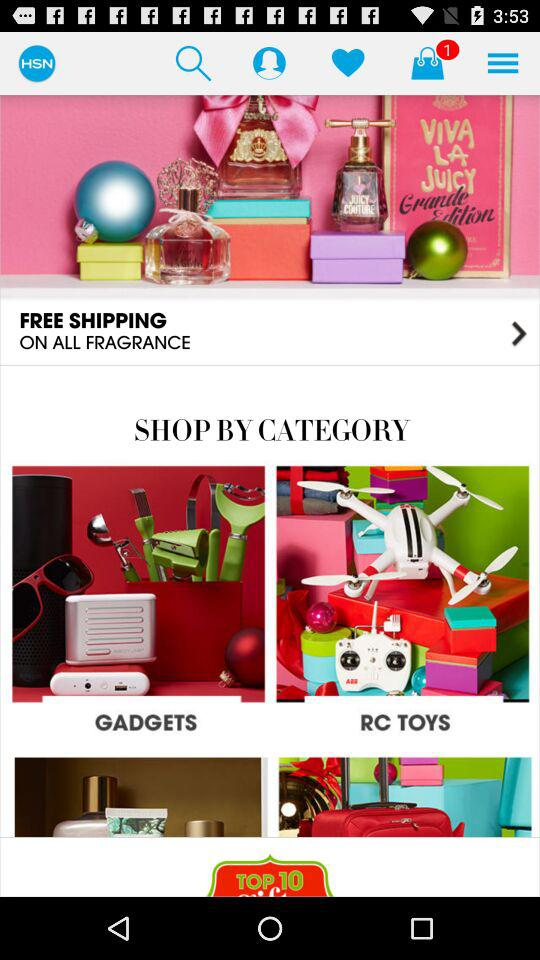How many items are in the bag? The item in the bag is 1. 